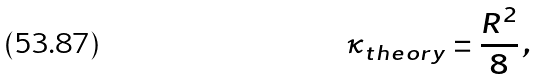<formula> <loc_0><loc_0><loc_500><loc_500>\kappa _ { t h e o r y } = \frac { R ^ { 2 } } { 8 } \, ,</formula> 